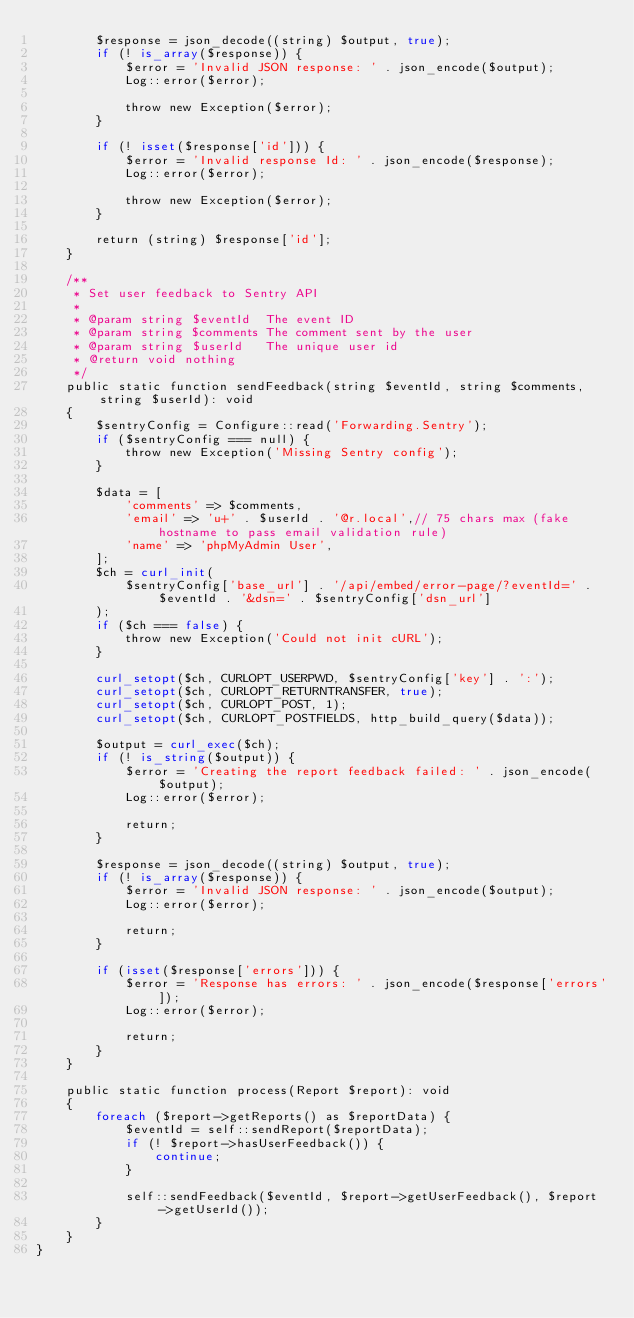<code> <loc_0><loc_0><loc_500><loc_500><_PHP_>        $response = json_decode((string) $output, true);
        if (! is_array($response)) {
            $error = 'Invalid JSON response: ' . json_encode($output);
            Log::error($error);

            throw new Exception($error);
        }

        if (! isset($response['id'])) {
            $error = 'Invalid response Id: ' . json_encode($response);
            Log::error($error);

            throw new Exception($error);
        }

        return (string) $response['id'];
    }

    /**
     * Set user feedback to Sentry API
     *
     * @param string $eventId  The event ID
     * @param string $comments The comment sent by the user
     * @param string $userId   The unique user id
     * @return void nothing
     */
    public static function sendFeedback(string $eventId, string $comments, string $userId): void
    {
        $sentryConfig = Configure::read('Forwarding.Sentry');
        if ($sentryConfig === null) {
            throw new Exception('Missing Sentry config');
        }

        $data = [
            'comments' => $comments,
            'email' => 'u+' . $userId . '@r.local',// 75 chars max (fake hostname to pass email validation rule)
            'name' => 'phpMyAdmin User',
        ];
        $ch = curl_init(
            $sentryConfig['base_url'] . '/api/embed/error-page/?eventId=' . $eventId . '&dsn=' . $sentryConfig['dsn_url']
        );
        if ($ch === false) {
            throw new Exception('Could not init cURL');
        }

        curl_setopt($ch, CURLOPT_USERPWD, $sentryConfig['key'] . ':');
        curl_setopt($ch, CURLOPT_RETURNTRANSFER, true);
        curl_setopt($ch, CURLOPT_POST, 1);
        curl_setopt($ch, CURLOPT_POSTFIELDS, http_build_query($data));

        $output = curl_exec($ch);
        if (! is_string($output)) {
            $error = 'Creating the report feedback failed: ' . json_encode($output);
            Log::error($error);

            return;
        }

        $response = json_decode((string) $output, true);
        if (! is_array($response)) {
            $error = 'Invalid JSON response: ' . json_encode($output);
            Log::error($error);

            return;
        }

        if (isset($response['errors'])) {
            $error = 'Response has errors: ' . json_encode($response['errors']);
            Log::error($error);

            return;
        }
    }

    public static function process(Report $report): void
    {
        foreach ($report->getReports() as $reportData) {
            $eventId = self::sendReport($reportData);
            if (! $report->hasUserFeedback()) {
                continue;
            }

            self::sendFeedback($eventId, $report->getUserFeedback(), $report->getUserId());
        }
    }
}
</code> 